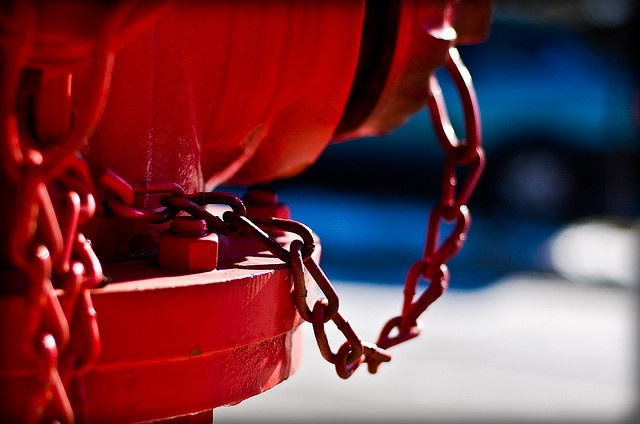Describe the objects in this image and their specific colors. I can see a fire hydrant in maroon, black, and lightgray tones in this image. 